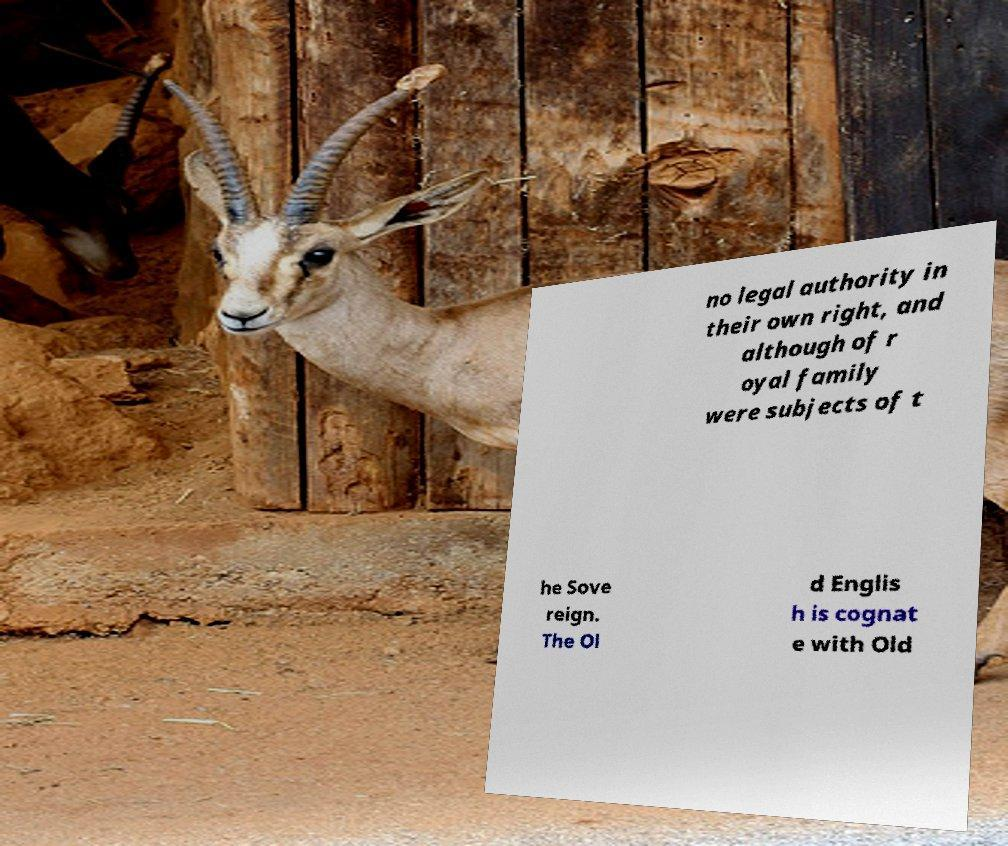Could you extract and type out the text from this image? no legal authority in their own right, and although of r oyal family were subjects of t he Sove reign. The Ol d Englis h is cognat e with Old 